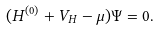<formula> <loc_0><loc_0><loc_500><loc_500>( H ^ { ( 0 ) } + V _ { H } - \mu ) \Psi = 0 .</formula> 